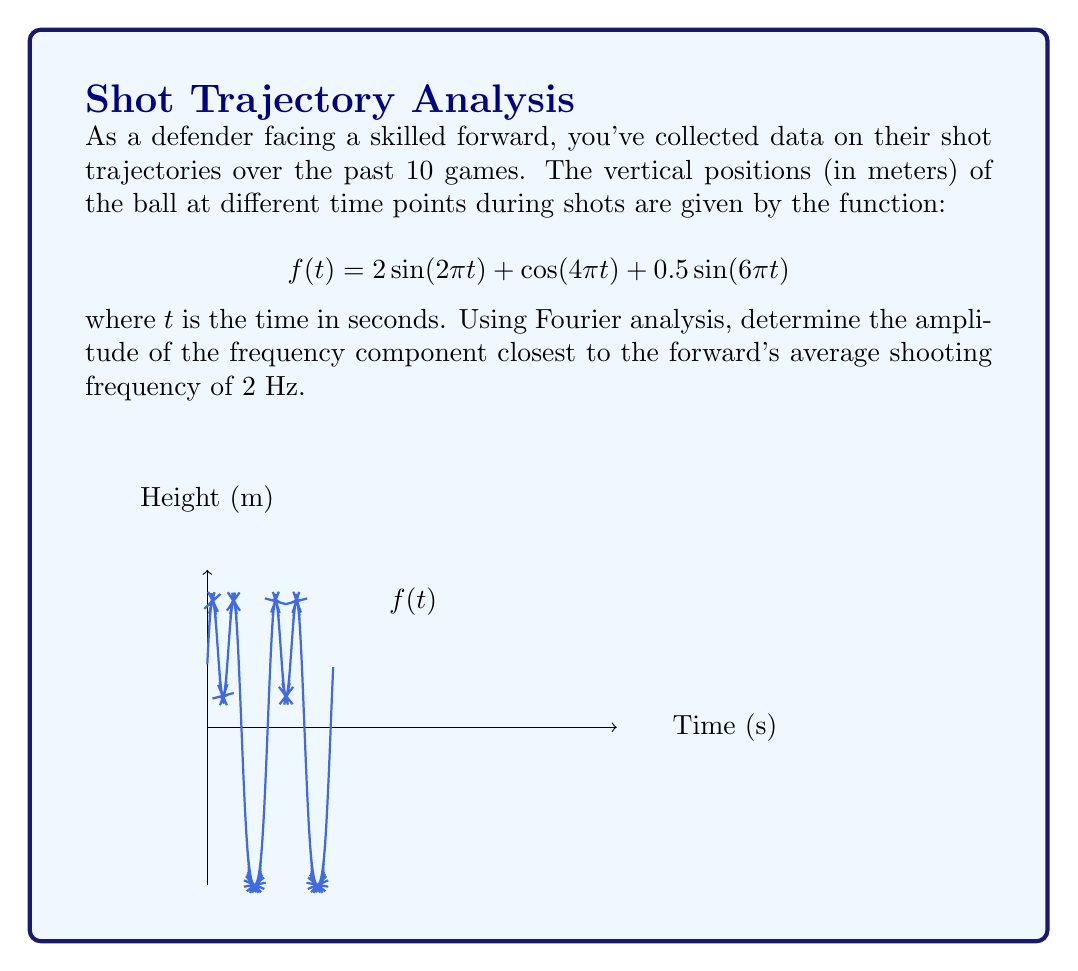Can you answer this question? To solve this problem, we'll follow these steps:

1) Identify the frequency components in the given function:
   $$f(t) = 2\sin(2\pi t) + \cos(4\pi t) + 0.5\sin(6\pi t)$$

2) The frequencies present are:
   - $2\pi t$ corresponds to 1 Hz
   - $4\pi t$ corresponds to 2 Hz
   - $6\pi t$ corresponds to 3 Hz

3) The forward's average shooting frequency is 2 Hz, which corresponds to the second term in the function.

4) In Fourier analysis, the amplitude of a cosine term is given directly by its coefficient. For a sine term, we need to consider that $\sin(x) = -\cos(x + \frac{\pi}{2})$.

5) The term closest to 2 Hz is $\cos(4\pi t)$, which has an amplitude of 1.

Therefore, the amplitude of the frequency component closest to the forward's average shooting frequency is 1 meter.
Answer: 1 meter 